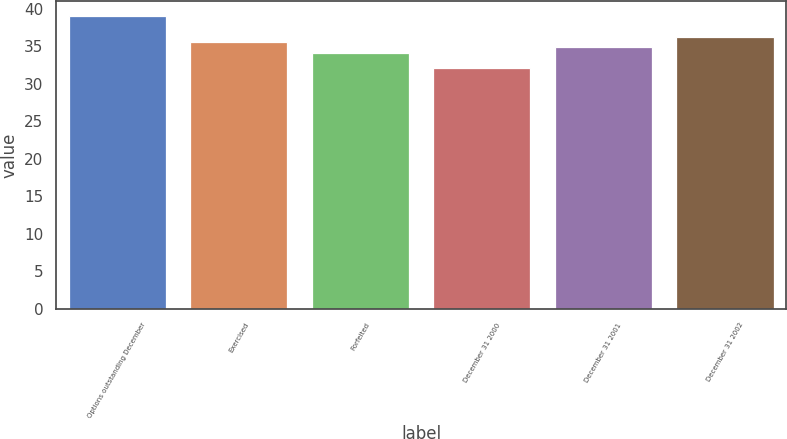Convert chart to OTSL. <chart><loc_0><loc_0><loc_500><loc_500><bar_chart><fcel>Options outstanding December<fcel>Exercised<fcel>Forfeited<fcel>December 31 2000<fcel>December 31 2001<fcel>December 31 2002<nl><fcel>39.05<fcel>35.55<fcel>34.15<fcel>32.05<fcel>34.85<fcel>36.25<nl></chart> 